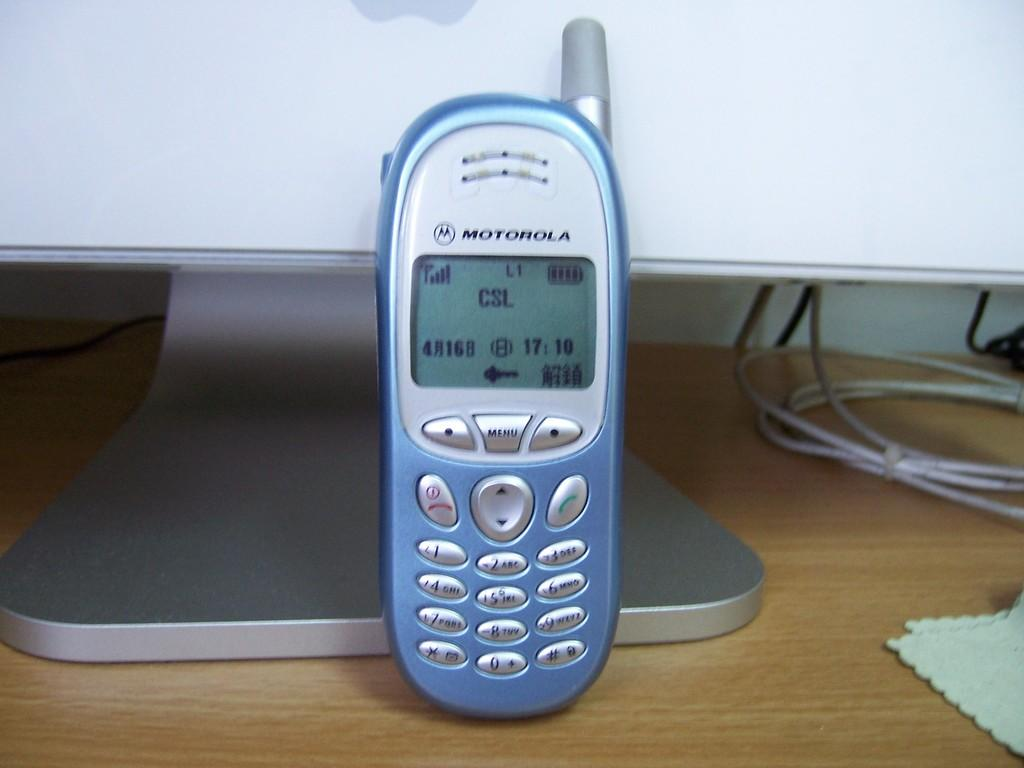Provide a one-sentence caption for the provided image. a blue, old fashioned mobile phone with csl on the screen. 